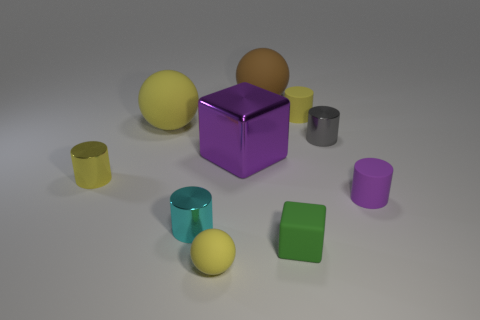Subtract all yellow matte spheres. How many spheres are left? 1 Subtract all green cubes. How many yellow balls are left? 2 Subtract all balls. How many objects are left? 7 Subtract 1 balls. How many balls are left? 2 Subtract all green cubes. How many cubes are left? 1 Subtract 0 gray balls. How many objects are left? 10 Subtract all yellow cylinders. Subtract all blue blocks. How many cylinders are left? 3 Subtract all large yellow spheres. Subtract all purple metallic cubes. How many objects are left? 8 Add 7 tiny purple rubber cylinders. How many tiny purple rubber cylinders are left? 8 Add 9 small spheres. How many small spheres exist? 10 